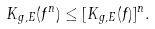<formula> <loc_0><loc_0><loc_500><loc_500>K _ { g , E } ( f ^ { n } ) \leq [ K _ { g , E } ( f ) ] ^ { n } .</formula> 